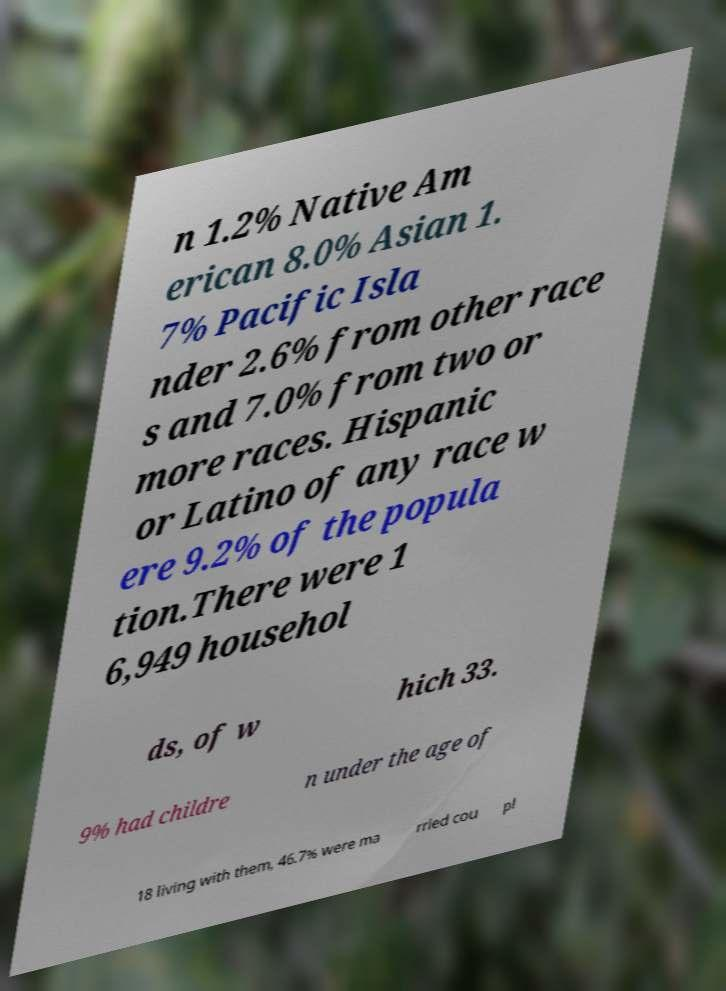Can you read and provide the text displayed in the image?This photo seems to have some interesting text. Can you extract and type it out for me? n 1.2% Native Am erican 8.0% Asian 1. 7% Pacific Isla nder 2.6% from other race s and 7.0% from two or more races. Hispanic or Latino of any race w ere 9.2% of the popula tion.There were 1 6,949 househol ds, of w hich 33. 9% had childre n under the age of 18 living with them, 46.7% were ma rried cou pl 